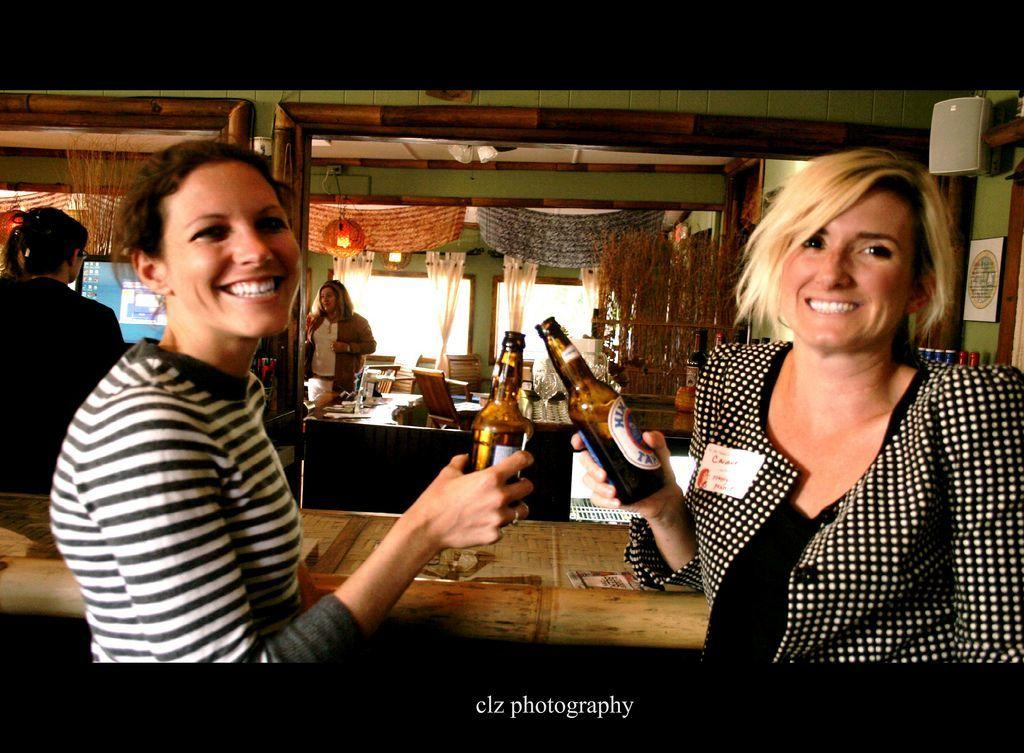How many women are present in the image? There are two women in the image. What are the women holding in the image? The women are holding glass bottles. What is the facial expression of the women in the image? The women are smiling. Can you describe the background of the image? There are other women, a lamp, and windows with curtains in the background of the image. What is the chance of a truck passing by in the image? There is no truck present in the image, so it is not possible to determine the chance of one passing by. 